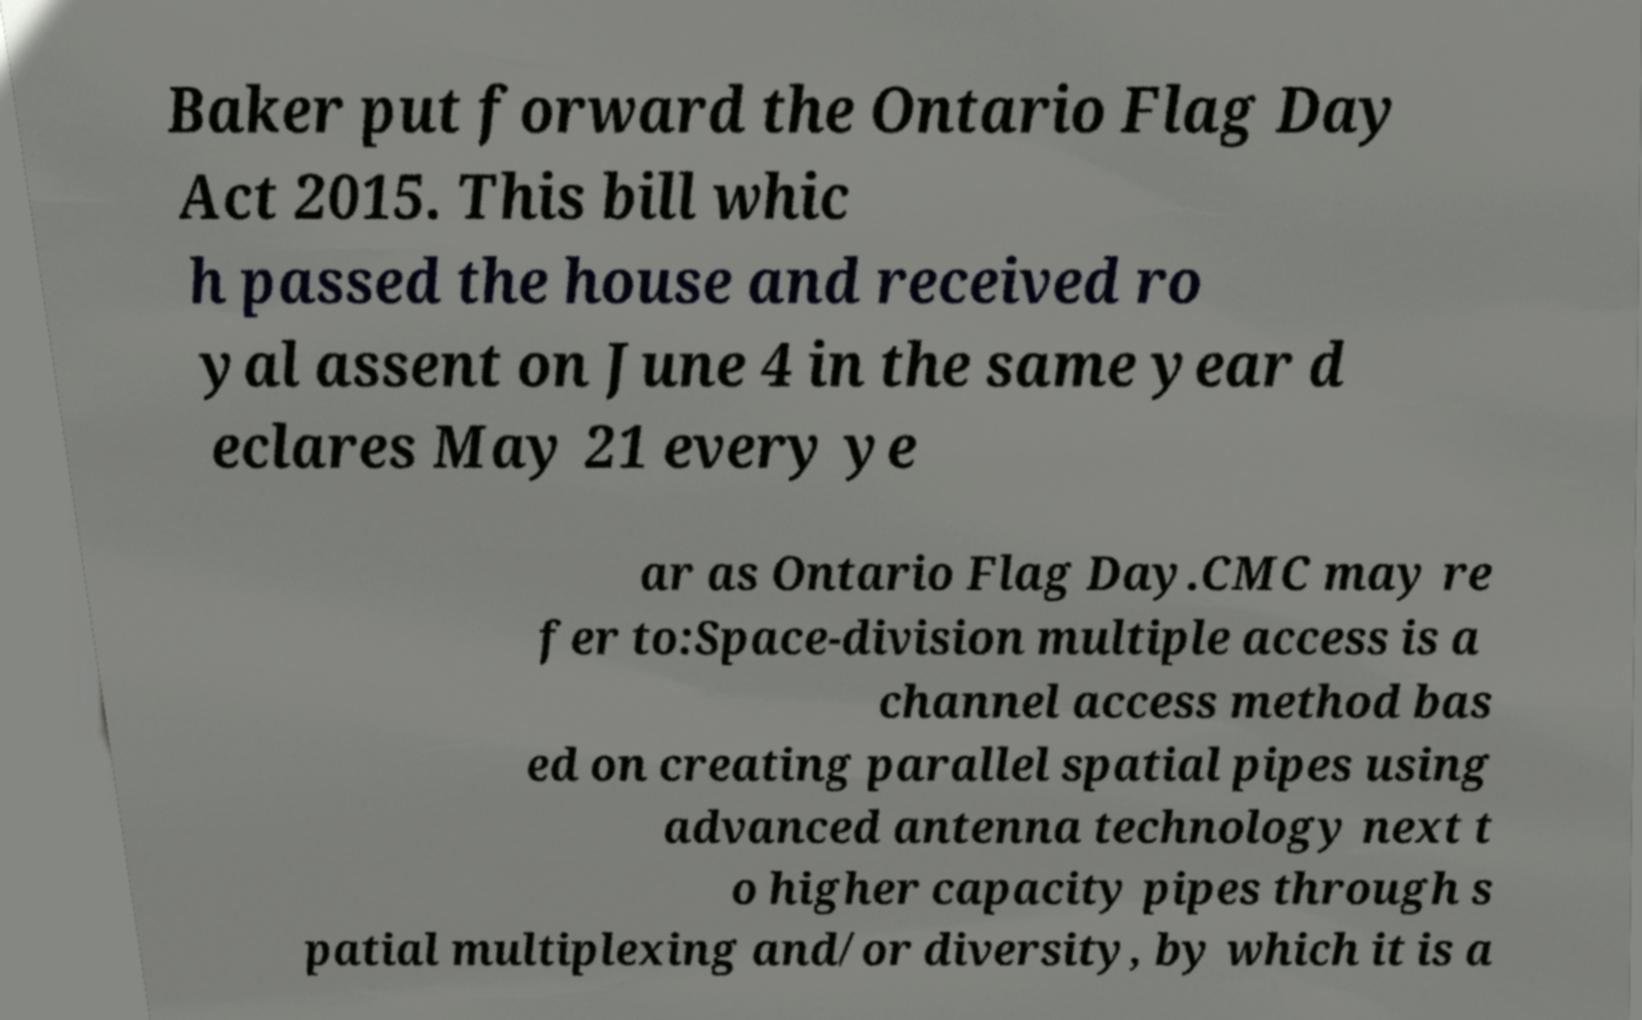For documentation purposes, I need the text within this image transcribed. Could you provide that? Baker put forward the Ontario Flag Day Act 2015. This bill whic h passed the house and received ro yal assent on June 4 in the same year d eclares May 21 every ye ar as Ontario Flag Day.CMC may re fer to:Space-division multiple access is a channel access method bas ed on creating parallel spatial pipes using advanced antenna technology next t o higher capacity pipes through s patial multiplexing and/or diversity, by which it is a 